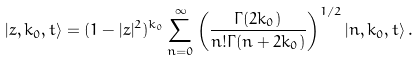Convert formula to latex. <formula><loc_0><loc_0><loc_500><loc_500>\left | z , k _ { 0 } , t \right > = ( 1 - | z | ^ { 2 } ) ^ { k _ { 0 } } \sum _ { n = 0 } ^ { \infty } \left ( \frac { \Gamma ( 2 k _ { 0 } ) } { n ! \Gamma ( n + 2 k _ { 0 } ) } \right ) ^ { 1 / 2 } \left | n , k _ { 0 } , t \right > .</formula> 